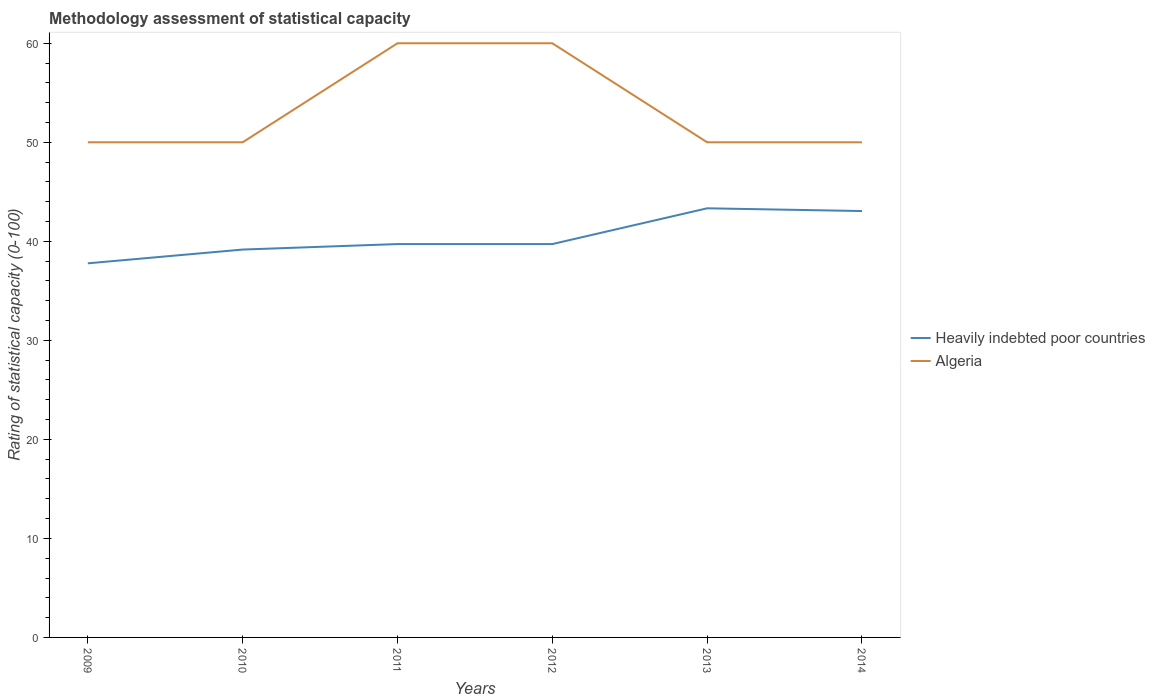Does the line corresponding to Algeria intersect with the line corresponding to Heavily indebted poor countries?
Your answer should be very brief. No. Is the number of lines equal to the number of legend labels?
Give a very brief answer. Yes. Across all years, what is the maximum rating of statistical capacity in Algeria?
Offer a very short reply. 50. In which year was the rating of statistical capacity in Algeria maximum?
Keep it short and to the point. 2009. What is the total rating of statistical capacity in Algeria in the graph?
Offer a very short reply. 10. What is the difference between the highest and the second highest rating of statistical capacity in Heavily indebted poor countries?
Offer a terse response. 5.56. Is the rating of statistical capacity in Heavily indebted poor countries strictly greater than the rating of statistical capacity in Algeria over the years?
Provide a short and direct response. Yes. How many lines are there?
Your answer should be compact. 2. How many years are there in the graph?
Provide a short and direct response. 6. What is the difference between two consecutive major ticks on the Y-axis?
Offer a terse response. 10. Are the values on the major ticks of Y-axis written in scientific E-notation?
Make the answer very short. No. Does the graph contain any zero values?
Offer a terse response. No. Does the graph contain grids?
Provide a succinct answer. No. Where does the legend appear in the graph?
Make the answer very short. Center right. What is the title of the graph?
Ensure brevity in your answer.  Methodology assessment of statistical capacity. Does "Saudi Arabia" appear as one of the legend labels in the graph?
Keep it short and to the point. No. What is the label or title of the X-axis?
Provide a short and direct response. Years. What is the label or title of the Y-axis?
Provide a short and direct response. Rating of statistical capacity (0-100). What is the Rating of statistical capacity (0-100) of Heavily indebted poor countries in 2009?
Offer a very short reply. 37.78. What is the Rating of statistical capacity (0-100) of Algeria in 2009?
Ensure brevity in your answer.  50. What is the Rating of statistical capacity (0-100) of Heavily indebted poor countries in 2010?
Your answer should be compact. 39.17. What is the Rating of statistical capacity (0-100) in Algeria in 2010?
Offer a very short reply. 50. What is the Rating of statistical capacity (0-100) in Heavily indebted poor countries in 2011?
Your answer should be compact. 39.72. What is the Rating of statistical capacity (0-100) in Algeria in 2011?
Your response must be concise. 60. What is the Rating of statistical capacity (0-100) in Heavily indebted poor countries in 2012?
Your answer should be very brief. 39.72. What is the Rating of statistical capacity (0-100) in Heavily indebted poor countries in 2013?
Ensure brevity in your answer.  43.33. What is the Rating of statistical capacity (0-100) in Algeria in 2013?
Make the answer very short. 50. What is the Rating of statistical capacity (0-100) of Heavily indebted poor countries in 2014?
Ensure brevity in your answer.  43.06. What is the Rating of statistical capacity (0-100) of Algeria in 2014?
Give a very brief answer. 50. Across all years, what is the maximum Rating of statistical capacity (0-100) in Heavily indebted poor countries?
Provide a short and direct response. 43.33. Across all years, what is the minimum Rating of statistical capacity (0-100) in Heavily indebted poor countries?
Offer a terse response. 37.78. Across all years, what is the minimum Rating of statistical capacity (0-100) of Algeria?
Provide a succinct answer. 50. What is the total Rating of statistical capacity (0-100) of Heavily indebted poor countries in the graph?
Provide a short and direct response. 242.78. What is the total Rating of statistical capacity (0-100) in Algeria in the graph?
Make the answer very short. 320. What is the difference between the Rating of statistical capacity (0-100) of Heavily indebted poor countries in 2009 and that in 2010?
Your response must be concise. -1.39. What is the difference between the Rating of statistical capacity (0-100) of Algeria in 2009 and that in 2010?
Ensure brevity in your answer.  0. What is the difference between the Rating of statistical capacity (0-100) of Heavily indebted poor countries in 2009 and that in 2011?
Keep it short and to the point. -1.94. What is the difference between the Rating of statistical capacity (0-100) of Algeria in 2009 and that in 2011?
Offer a very short reply. -10. What is the difference between the Rating of statistical capacity (0-100) in Heavily indebted poor countries in 2009 and that in 2012?
Your response must be concise. -1.94. What is the difference between the Rating of statistical capacity (0-100) of Heavily indebted poor countries in 2009 and that in 2013?
Your answer should be compact. -5.56. What is the difference between the Rating of statistical capacity (0-100) in Heavily indebted poor countries in 2009 and that in 2014?
Make the answer very short. -5.28. What is the difference between the Rating of statistical capacity (0-100) in Algeria in 2009 and that in 2014?
Provide a short and direct response. 0. What is the difference between the Rating of statistical capacity (0-100) of Heavily indebted poor countries in 2010 and that in 2011?
Your answer should be compact. -0.56. What is the difference between the Rating of statistical capacity (0-100) in Algeria in 2010 and that in 2011?
Your answer should be very brief. -10. What is the difference between the Rating of statistical capacity (0-100) of Heavily indebted poor countries in 2010 and that in 2012?
Your answer should be compact. -0.56. What is the difference between the Rating of statistical capacity (0-100) in Algeria in 2010 and that in 2012?
Offer a very short reply. -10. What is the difference between the Rating of statistical capacity (0-100) of Heavily indebted poor countries in 2010 and that in 2013?
Provide a short and direct response. -4.17. What is the difference between the Rating of statistical capacity (0-100) of Algeria in 2010 and that in 2013?
Provide a succinct answer. 0. What is the difference between the Rating of statistical capacity (0-100) of Heavily indebted poor countries in 2010 and that in 2014?
Provide a succinct answer. -3.89. What is the difference between the Rating of statistical capacity (0-100) of Algeria in 2010 and that in 2014?
Keep it short and to the point. 0. What is the difference between the Rating of statistical capacity (0-100) of Heavily indebted poor countries in 2011 and that in 2013?
Give a very brief answer. -3.61. What is the difference between the Rating of statistical capacity (0-100) in Algeria in 2011 and that in 2013?
Your response must be concise. 10. What is the difference between the Rating of statistical capacity (0-100) in Algeria in 2011 and that in 2014?
Your response must be concise. 10. What is the difference between the Rating of statistical capacity (0-100) in Heavily indebted poor countries in 2012 and that in 2013?
Your response must be concise. -3.61. What is the difference between the Rating of statistical capacity (0-100) of Algeria in 2012 and that in 2013?
Offer a terse response. 10. What is the difference between the Rating of statistical capacity (0-100) in Heavily indebted poor countries in 2012 and that in 2014?
Offer a terse response. -3.33. What is the difference between the Rating of statistical capacity (0-100) of Heavily indebted poor countries in 2013 and that in 2014?
Your answer should be compact. 0.28. What is the difference between the Rating of statistical capacity (0-100) of Algeria in 2013 and that in 2014?
Make the answer very short. 0. What is the difference between the Rating of statistical capacity (0-100) in Heavily indebted poor countries in 2009 and the Rating of statistical capacity (0-100) in Algeria in 2010?
Give a very brief answer. -12.22. What is the difference between the Rating of statistical capacity (0-100) of Heavily indebted poor countries in 2009 and the Rating of statistical capacity (0-100) of Algeria in 2011?
Your answer should be compact. -22.22. What is the difference between the Rating of statistical capacity (0-100) in Heavily indebted poor countries in 2009 and the Rating of statistical capacity (0-100) in Algeria in 2012?
Your answer should be very brief. -22.22. What is the difference between the Rating of statistical capacity (0-100) in Heavily indebted poor countries in 2009 and the Rating of statistical capacity (0-100) in Algeria in 2013?
Keep it short and to the point. -12.22. What is the difference between the Rating of statistical capacity (0-100) of Heavily indebted poor countries in 2009 and the Rating of statistical capacity (0-100) of Algeria in 2014?
Your answer should be very brief. -12.22. What is the difference between the Rating of statistical capacity (0-100) in Heavily indebted poor countries in 2010 and the Rating of statistical capacity (0-100) in Algeria in 2011?
Your answer should be compact. -20.83. What is the difference between the Rating of statistical capacity (0-100) in Heavily indebted poor countries in 2010 and the Rating of statistical capacity (0-100) in Algeria in 2012?
Offer a terse response. -20.83. What is the difference between the Rating of statistical capacity (0-100) in Heavily indebted poor countries in 2010 and the Rating of statistical capacity (0-100) in Algeria in 2013?
Your answer should be compact. -10.83. What is the difference between the Rating of statistical capacity (0-100) of Heavily indebted poor countries in 2010 and the Rating of statistical capacity (0-100) of Algeria in 2014?
Provide a short and direct response. -10.83. What is the difference between the Rating of statistical capacity (0-100) in Heavily indebted poor countries in 2011 and the Rating of statistical capacity (0-100) in Algeria in 2012?
Provide a short and direct response. -20.28. What is the difference between the Rating of statistical capacity (0-100) in Heavily indebted poor countries in 2011 and the Rating of statistical capacity (0-100) in Algeria in 2013?
Offer a very short reply. -10.28. What is the difference between the Rating of statistical capacity (0-100) of Heavily indebted poor countries in 2011 and the Rating of statistical capacity (0-100) of Algeria in 2014?
Provide a short and direct response. -10.28. What is the difference between the Rating of statistical capacity (0-100) of Heavily indebted poor countries in 2012 and the Rating of statistical capacity (0-100) of Algeria in 2013?
Ensure brevity in your answer.  -10.28. What is the difference between the Rating of statistical capacity (0-100) in Heavily indebted poor countries in 2012 and the Rating of statistical capacity (0-100) in Algeria in 2014?
Make the answer very short. -10.28. What is the difference between the Rating of statistical capacity (0-100) of Heavily indebted poor countries in 2013 and the Rating of statistical capacity (0-100) of Algeria in 2014?
Ensure brevity in your answer.  -6.67. What is the average Rating of statistical capacity (0-100) of Heavily indebted poor countries per year?
Offer a very short reply. 40.46. What is the average Rating of statistical capacity (0-100) of Algeria per year?
Provide a short and direct response. 53.33. In the year 2009, what is the difference between the Rating of statistical capacity (0-100) of Heavily indebted poor countries and Rating of statistical capacity (0-100) of Algeria?
Offer a very short reply. -12.22. In the year 2010, what is the difference between the Rating of statistical capacity (0-100) in Heavily indebted poor countries and Rating of statistical capacity (0-100) in Algeria?
Keep it short and to the point. -10.83. In the year 2011, what is the difference between the Rating of statistical capacity (0-100) in Heavily indebted poor countries and Rating of statistical capacity (0-100) in Algeria?
Offer a terse response. -20.28. In the year 2012, what is the difference between the Rating of statistical capacity (0-100) of Heavily indebted poor countries and Rating of statistical capacity (0-100) of Algeria?
Your response must be concise. -20.28. In the year 2013, what is the difference between the Rating of statistical capacity (0-100) of Heavily indebted poor countries and Rating of statistical capacity (0-100) of Algeria?
Make the answer very short. -6.67. In the year 2014, what is the difference between the Rating of statistical capacity (0-100) of Heavily indebted poor countries and Rating of statistical capacity (0-100) of Algeria?
Offer a very short reply. -6.94. What is the ratio of the Rating of statistical capacity (0-100) in Heavily indebted poor countries in 2009 to that in 2010?
Offer a very short reply. 0.96. What is the ratio of the Rating of statistical capacity (0-100) in Heavily indebted poor countries in 2009 to that in 2011?
Offer a terse response. 0.95. What is the ratio of the Rating of statistical capacity (0-100) of Heavily indebted poor countries in 2009 to that in 2012?
Keep it short and to the point. 0.95. What is the ratio of the Rating of statistical capacity (0-100) of Heavily indebted poor countries in 2009 to that in 2013?
Give a very brief answer. 0.87. What is the ratio of the Rating of statistical capacity (0-100) in Algeria in 2009 to that in 2013?
Your answer should be very brief. 1. What is the ratio of the Rating of statistical capacity (0-100) in Heavily indebted poor countries in 2009 to that in 2014?
Offer a very short reply. 0.88. What is the ratio of the Rating of statistical capacity (0-100) of Algeria in 2009 to that in 2014?
Keep it short and to the point. 1. What is the ratio of the Rating of statistical capacity (0-100) in Heavily indebted poor countries in 2010 to that in 2011?
Keep it short and to the point. 0.99. What is the ratio of the Rating of statistical capacity (0-100) of Heavily indebted poor countries in 2010 to that in 2013?
Ensure brevity in your answer.  0.9. What is the ratio of the Rating of statistical capacity (0-100) of Heavily indebted poor countries in 2010 to that in 2014?
Keep it short and to the point. 0.91. What is the ratio of the Rating of statistical capacity (0-100) in Heavily indebted poor countries in 2011 to that in 2012?
Offer a very short reply. 1. What is the ratio of the Rating of statistical capacity (0-100) in Algeria in 2011 to that in 2012?
Keep it short and to the point. 1. What is the ratio of the Rating of statistical capacity (0-100) of Heavily indebted poor countries in 2011 to that in 2013?
Your response must be concise. 0.92. What is the ratio of the Rating of statistical capacity (0-100) in Algeria in 2011 to that in 2013?
Keep it short and to the point. 1.2. What is the ratio of the Rating of statistical capacity (0-100) in Heavily indebted poor countries in 2011 to that in 2014?
Make the answer very short. 0.92. What is the ratio of the Rating of statistical capacity (0-100) of Algeria in 2012 to that in 2013?
Your response must be concise. 1.2. What is the ratio of the Rating of statistical capacity (0-100) in Heavily indebted poor countries in 2012 to that in 2014?
Your response must be concise. 0.92. What is the ratio of the Rating of statistical capacity (0-100) of Heavily indebted poor countries in 2013 to that in 2014?
Make the answer very short. 1.01. What is the difference between the highest and the second highest Rating of statistical capacity (0-100) of Heavily indebted poor countries?
Provide a succinct answer. 0.28. What is the difference between the highest and the second highest Rating of statistical capacity (0-100) in Algeria?
Offer a very short reply. 0. What is the difference between the highest and the lowest Rating of statistical capacity (0-100) of Heavily indebted poor countries?
Your response must be concise. 5.56. What is the difference between the highest and the lowest Rating of statistical capacity (0-100) of Algeria?
Ensure brevity in your answer.  10. 